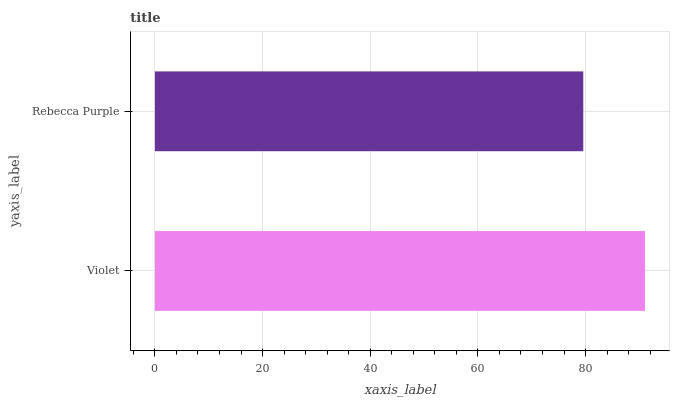Is Rebecca Purple the minimum?
Answer yes or no. Yes. Is Violet the maximum?
Answer yes or no. Yes. Is Rebecca Purple the maximum?
Answer yes or no. No. Is Violet greater than Rebecca Purple?
Answer yes or no. Yes. Is Rebecca Purple less than Violet?
Answer yes or no. Yes. Is Rebecca Purple greater than Violet?
Answer yes or no. No. Is Violet less than Rebecca Purple?
Answer yes or no. No. Is Violet the high median?
Answer yes or no. Yes. Is Rebecca Purple the low median?
Answer yes or no. Yes. Is Rebecca Purple the high median?
Answer yes or no. No. Is Violet the low median?
Answer yes or no. No. 